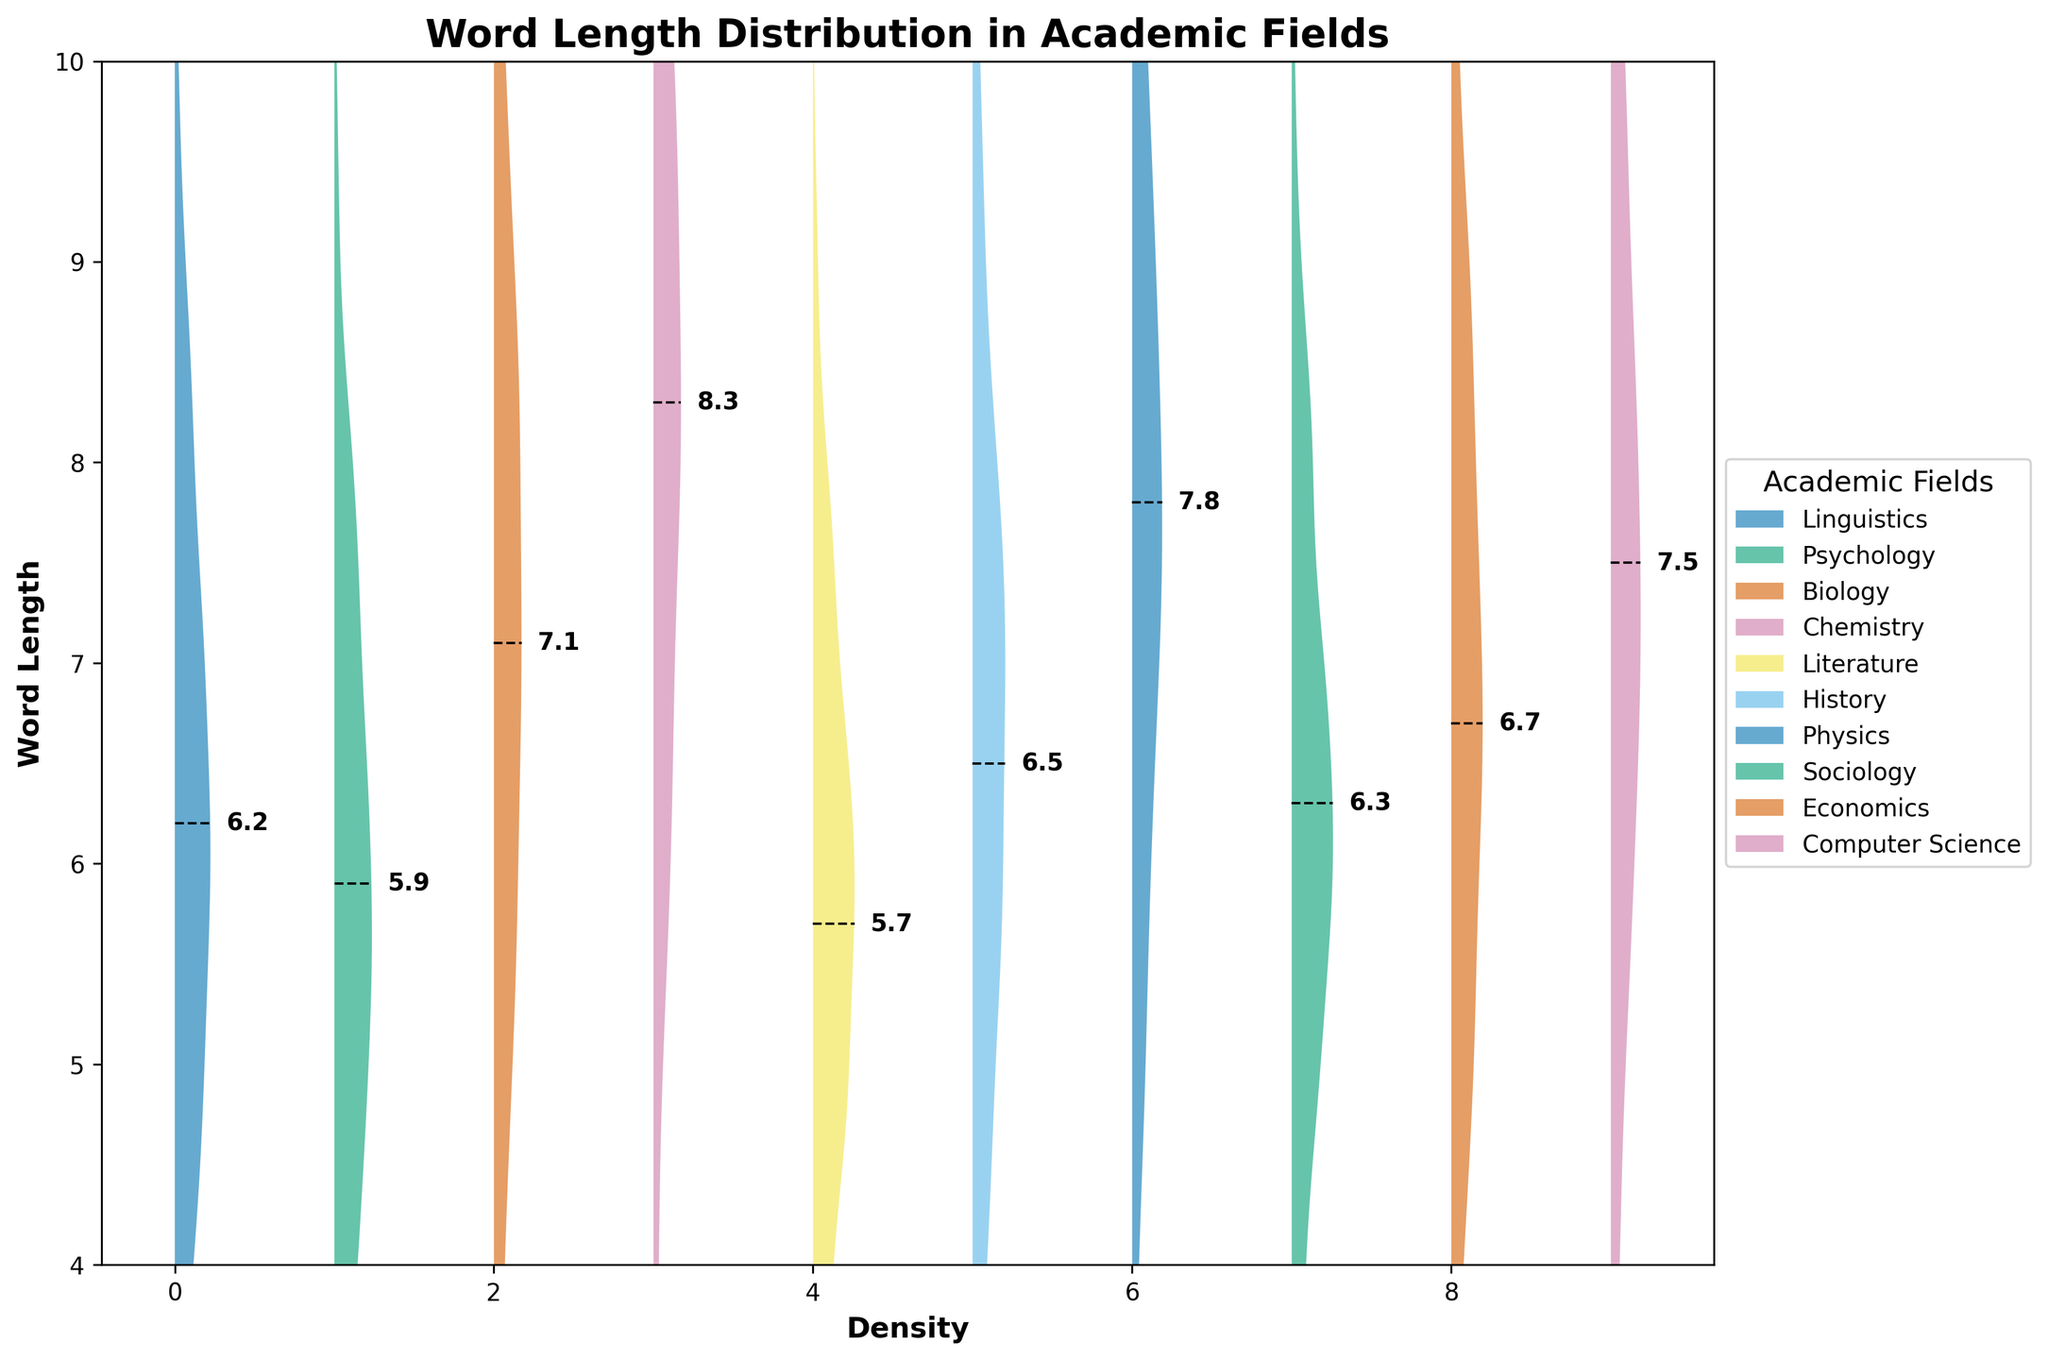What's the title of the plot? The title of the plot is usually found at the top and helps to understand the purpose of the figure.
Answer: Word Length Distribution in Academic Fields What is the average word length for the Chemistry field? The average word length can be found next to the dashed line specifically labeled for the Chemistry field.
Answer: 8.3 Which field has the shortest average word length? To find the field with the shortest average word length, look at the dashed lines and the corresponding text labels. The shortest average should be the smallest numerical value.
Answer: Literature How does the word length distribution for Physics compare to Biology? Compare both the central tendency (average) and spread (distribution width) by observing their respective positions and density spread in the figure.
Answer: Physics has a slightly smaller average word length with a broader distribution What is the range of standard deviations across all fields? Compute the range by finding the smallest and largest standard deviation values in the figure. Standard deviation indicates the spread of word lengths around the average.
Answer: 1.5 to 2.4 Which field has the most similar word length distribution to Linguistics? To find the most similar field, compare the shapes and central positions (averages) of the distributions.
Answer: Sociology How does the word length distribution for Computer Science differ from Psychology? Compare both fields by looking at their density shapes, average positions, and spread.
Answer: Computer Science has a higher average word length and a wider spread than Psychology Which field's average word length is closest to 7? Identify the distributions and their average labels close to a word length of 7.
Answer: Biology Between History and Economics, which has a higher average word length? Compare the vertical position of the dashed lines and their labels for both fields.
Answer: Economics How many fields have an average word length greater than 7? Count the number of fields with average values above 7, as indicated by their labeled averages and dashed lines.
Answer: 4 